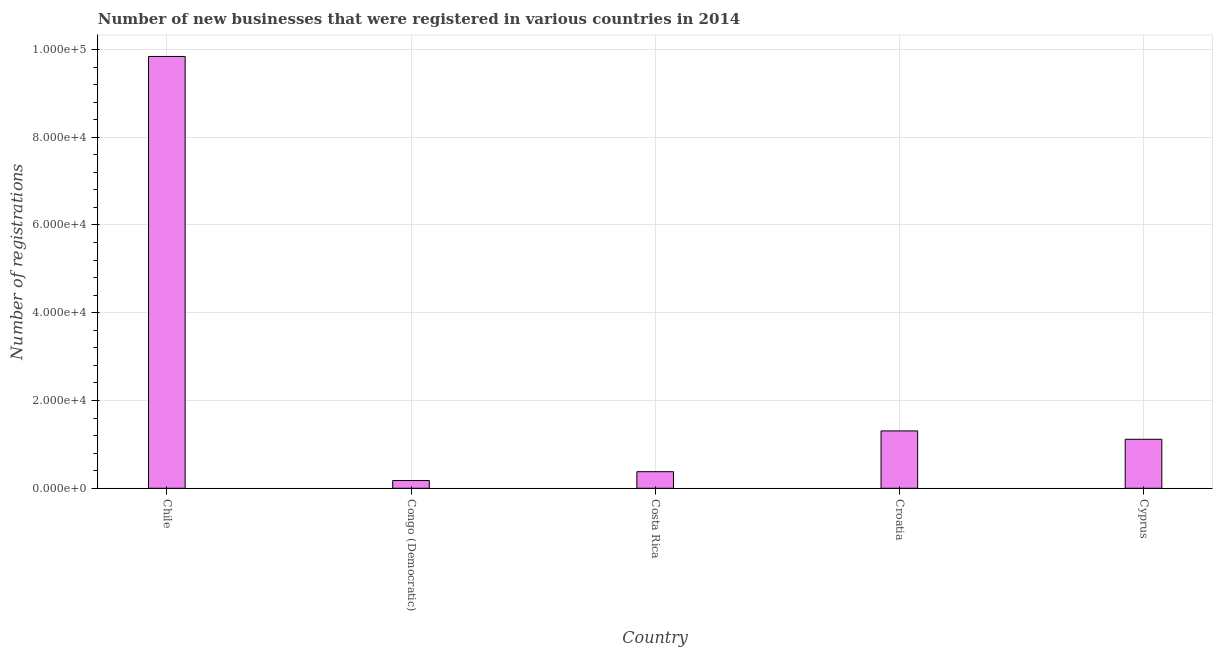Does the graph contain any zero values?
Your answer should be compact. No. Does the graph contain grids?
Provide a short and direct response. Yes. What is the title of the graph?
Make the answer very short. Number of new businesses that were registered in various countries in 2014. What is the label or title of the X-axis?
Offer a terse response. Country. What is the label or title of the Y-axis?
Give a very brief answer. Number of registrations. What is the number of new business registrations in Cyprus?
Your response must be concise. 1.12e+04. Across all countries, what is the maximum number of new business registrations?
Make the answer very short. 9.84e+04. Across all countries, what is the minimum number of new business registrations?
Provide a short and direct response. 1765. In which country was the number of new business registrations minimum?
Provide a short and direct response. Congo (Democratic). What is the sum of the number of new business registrations?
Ensure brevity in your answer.  1.28e+05. What is the difference between the number of new business registrations in Congo (Democratic) and Cyprus?
Offer a terse response. -9404. What is the average number of new business registrations per country?
Your answer should be compact. 2.56e+04. What is the median number of new business registrations?
Your answer should be compact. 1.12e+04. What is the ratio of the number of new business registrations in Chile to that in Croatia?
Make the answer very short. 7.53. Is the number of new business registrations in Chile less than that in Cyprus?
Your response must be concise. No. What is the difference between the highest and the second highest number of new business registrations?
Ensure brevity in your answer.  8.53e+04. Is the sum of the number of new business registrations in Croatia and Cyprus greater than the maximum number of new business registrations across all countries?
Provide a short and direct response. No. What is the difference between the highest and the lowest number of new business registrations?
Ensure brevity in your answer.  9.66e+04. In how many countries, is the number of new business registrations greater than the average number of new business registrations taken over all countries?
Keep it short and to the point. 1. What is the difference between two consecutive major ticks on the Y-axis?
Provide a short and direct response. 2.00e+04. What is the Number of registrations of Chile?
Give a very brief answer. 9.84e+04. What is the Number of registrations in Congo (Democratic)?
Give a very brief answer. 1765. What is the Number of registrations in Costa Rica?
Your answer should be very brief. 3778. What is the Number of registrations in Croatia?
Provide a succinct answer. 1.31e+04. What is the Number of registrations of Cyprus?
Provide a short and direct response. 1.12e+04. What is the difference between the Number of registrations in Chile and Congo (Democratic)?
Give a very brief answer. 9.66e+04. What is the difference between the Number of registrations in Chile and Costa Rica?
Offer a very short reply. 9.46e+04. What is the difference between the Number of registrations in Chile and Croatia?
Offer a very short reply. 8.53e+04. What is the difference between the Number of registrations in Chile and Cyprus?
Ensure brevity in your answer.  8.72e+04. What is the difference between the Number of registrations in Congo (Democratic) and Costa Rica?
Your answer should be very brief. -2013. What is the difference between the Number of registrations in Congo (Democratic) and Croatia?
Offer a terse response. -1.13e+04. What is the difference between the Number of registrations in Congo (Democratic) and Cyprus?
Provide a short and direct response. -9404. What is the difference between the Number of registrations in Costa Rica and Croatia?
Offer a terse response. -9295. What is the difference between the Number of registrations in Costa Rica and Cyprus?
Give a very brief answer. -7391. What is the difference between the Number of registrations in Croatia and Cyprus?
Offer a very short reply. 1904. What is the ratio of the Number of registrations in Chile to that in Congo (Democratic)?
Your answer should be compact. 55.75. What is the ratio of the Number of registrations in Chile to that in Costa Rica?
Your response must be concise. 26.05. What is the ratio of the Number of registrations in Chile to that in Croatia?
Your answer should be very brief. 7.53. What is the ratio of the Number of registrations in Chile to that in Cyprus?
Your response must be concise. 8.81. What is the ratio of the Number of registrations in Congo (Democratic) to that in Costa Rica?
Offer a terse response. 0.47. What is the ratio of the Number of registrations in Congo (Democratic) to that in Croatia?
Keep it short and to the point. 0.14. What is the ratio of the Number of registrations in Congo (Democratic) to that in Cyprus?
Make the answer very short. 0.16. What is the ratio of the Number of registrations in Costa Rica to that in Croatia?
Provide a short and direct response. 0.29. What is the ratio of the Number of registrations in Costa Rica to that in Cyprus?
Your answer should be very brief. 0.34. What is the ratio of the Number of registrations in Croatia to that in Cyprus?
Provide a short and direct response. 1.17. 